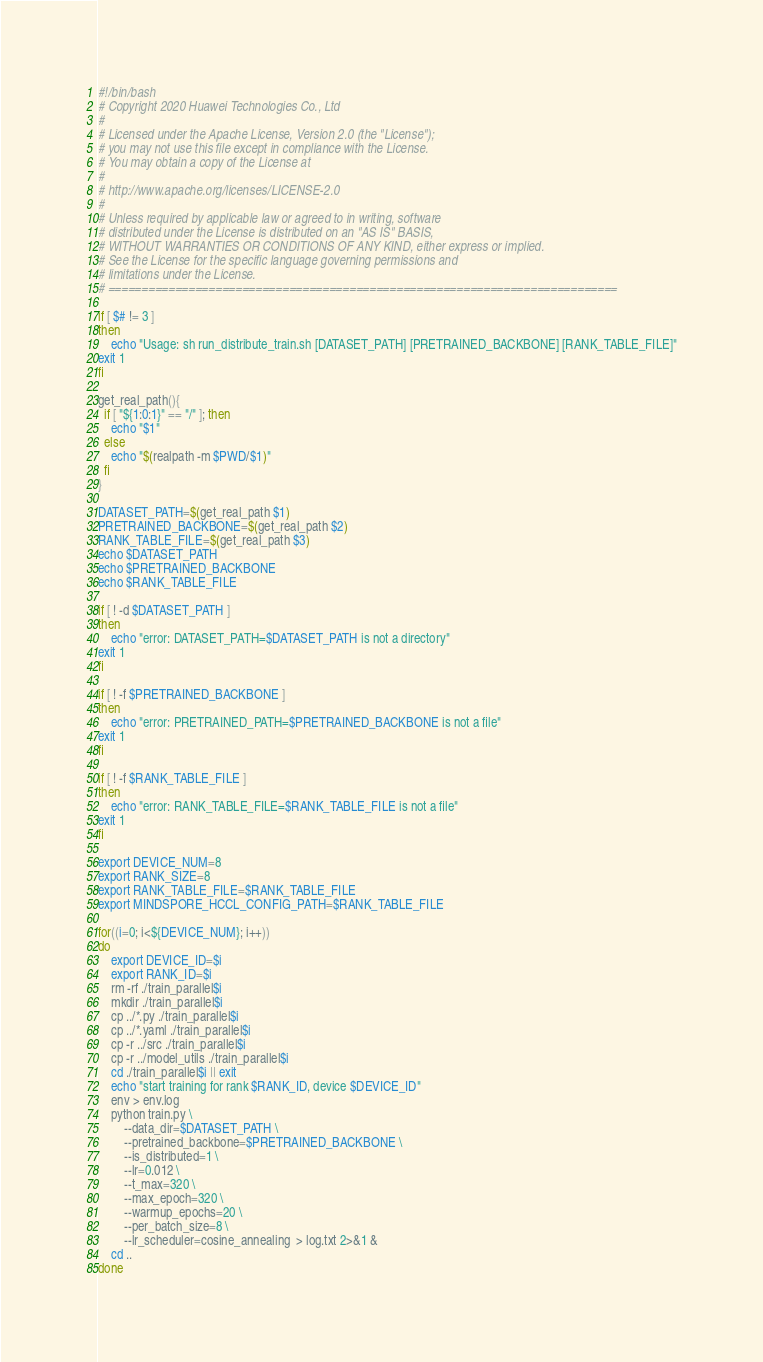<code> <loc_0><loc_0><loc_500><loc_500><_Bash_>#!/bin/bash
# Copyright 2020 Huawei Technologies Co., Ltd
#
# Licensed under the Apache License, Version 2.0 (the "License");
# you may not use this file except in compliance with the License.
# You may obtain a copy of the License at
#
# http://www.apache.org/licenses/LICENSE-2.0
#
# Unless required by applicable law or agreed to in writing, software
# distributed under the License is distributed on an "AS IS" BASIS,
# WITHOUT WARRANTIES OR CONDITIONS OF ANY KIND, either express or implied.
# See the License for the specific language governing permissions and
# limitations under the License.
# ============================================================================

if [ $# != 3 ]
then
    echo "Usage: sh run_distribute_train.sh [DATASET_PATH] [PRETRAINED_BACKBONE] [RANK_TABLE_FILE]"
exit 1
fi

get_real_path(){
  if [ "${1:0:1}" == "/" ]; then
    echo "$1"
  else
    echo "$(realpath -m $PWD/$1)"
  fi
}

DATASET_PATH=$(get_real_path $1)
PRETRAINED_BACKBONE=$(get_real_path $2)
RANK_TABLE_FILE=$(get_real_path $3)
echo $DATASET_PATH
echo $PRETRAINED_BACKBONE
echo $RANK_TABLE_FILE

if [ ! -d $DATASET_PATH ]
then
    echo "error: DATASET_PATH=$DATASET_PATH is not a directory"
exit 1
fi

if [ ! -f $PRETRAINED_BACKBONE ]
then
    echo "error: PRETRAINED_PATH=$PRETRAINED_BACKBONE is not a file"
exit 1
fi

if [ ! -f $RANK_TABLE_FILE ]
then
    echo "error: RANK_TABLE_FILE=$RANK_TABLE_FILE is not a file"
exit 1
fi

export DEVICE_NUM=8
export RANK_SIZE=8
export RANK_TABLE_FILE=$RANK_TABLE_FILE
export MINDSPORE_HCCL_CONFIG_PATH=$RANK_TABLE_FILE

for((i=0; i<${DEVICE_NUM}; i++))
do
    export DEVICE_ID=$i
    export RANK_ID=$i
    rm -rf ./train_parallel$i
    mkdir ./train_parallel$i
    cp ../*.py ./train_parallel$i
    cp ../*.yaml ./train_parallel$i
    cp -r ../src ./train_parallel$i
    cp -r ../model_utils ./train_parallel$i
    cd ./train_parallel$i || exit
    echo "start training for rank $RANK_ID, device $DEVICE_ID"
    env > env.log
    python train.py \
        --data_dir=$DATASET_PATH \
        --pretrained_backbone=$PRETRAINED_BACKBONE \
        --is_distributed=1 \
        --lr=0.012 \
        --t_max=320 \
        --max_epoch=320 \
        --warmup_epochs=20 \
        --per_batch_size=8 \
        --lr_scheduler=cosine_annealing  > log.txt 2>&1 &
    cd ..
done
</code> 